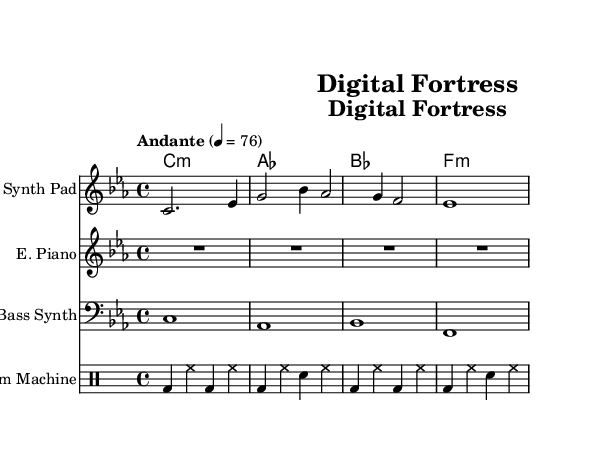What is the key signature of this music? The key signature is C minor, which has three flats: B♭, E♭, and A♭. It can be identified from the key signature indicated in the beginning of the sheet music.
Answer: C minor What is the time signature of the score? The time signature is 4/4, which indicates there are four beats in a measure, and the quarter note gets one beat. This can be inferred from the notation before the first measure in the sheet music.
Answer: 4/4 What is the tempo marking given in the music? The tempo marking is "Andante," which suggests a moderate walking pace. The metronome marking of 76 beats per minute also indicates the speed. This can be seen at the beginning of the score.
Answer: Andante How many instruments are indicated in the score? The score features four instruments: Synth Pad, Electric Piano, Bass Synth, and Drum Machine. Each instrument has its own staff, which is clearly labeled in the music sheet.
Answer: Four Which instrument plays the bass line? The Bass Synth instrument provides the bass line in this piece. It is indicated at the bottom of the score on a separate staff and is characterized by lower pitch notes.
Answer: Bass Synth What chord is notated as the first chord in this score? The first chord notated is C minor, which is indicated in the chord names section at the start of the score. The chord structure is aligned with the symbol in the chord names staff.
Answer: C:m What type of music is this score composed for? This score is composed for ambient electronic soundtracks, specifically designed to evoke a sci-fi theme about digital security, as inferred from the title "Digital Fortress" and the overall style of the music.
Answer: Ambient electronic 